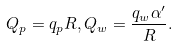Convert formula to latex. <formula><loc_0><loc_0><loc_500><loc_500>Q _ { p } = q _ { p } R , Q _ { w } = \frac { q _ { w } \alpha ^ { \prime } } { R } .</formula> 